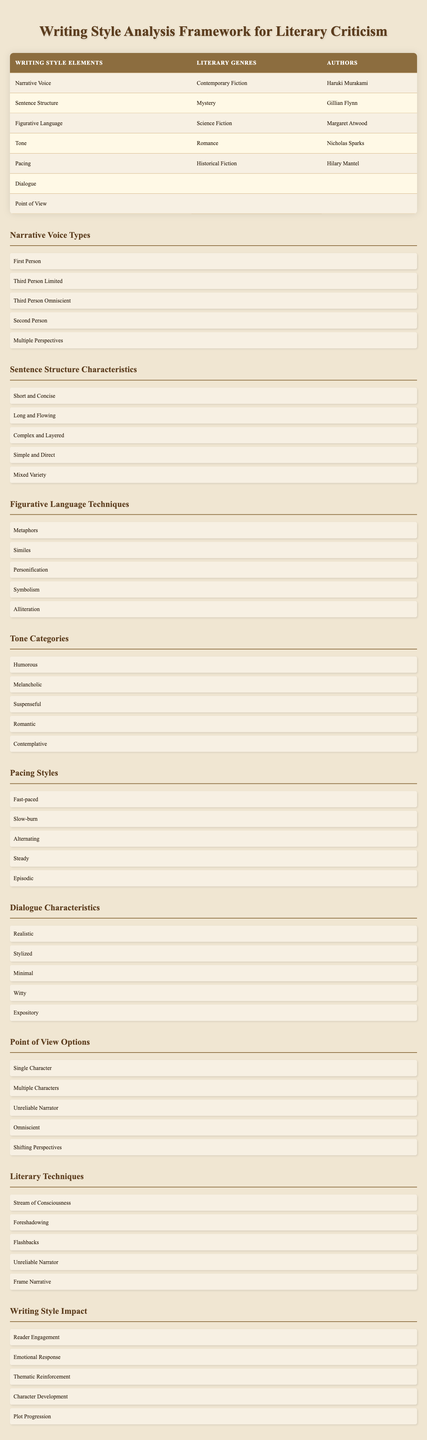What type of Narrative Voice is associated with Haruki Murakami? The table indicates that Haruki Murakami's work features a Narrative Voice in Contemporary Fiction. Although specific voice type isn't listed for him here, he often employs First Person in his narratives.
Answer: First Person Which author is linked to the Sentence Structure element in Mystery genre? According to the table, Gillian Flynn’s work relates to the Sentence Structure characteristic in the Mystery genre as shown in the corresponding row.
Answer: Gillian Flynn Is there a Dialogue characteristic directly provided in the table? The table lists a row for Dialogue but does not specify any authors or genres associated with it, indicating that no specific information is provided for this element.
Answer: No Which author is linked to Tone in the Romance genre? The table directly connects Nicholas Sparks to the Tone characteristic in the Romance genre, as shown in the respective row.
Answer: Nicholas Sparks Can you identify two Literary Genres represented in the table? The table lists Contemporary Fiction, Mystery, Science Fiction, Romance, and Historical Fiction as Literary Genres. Choosing any two of these would be acceptable, e.g., Contemporary Fiction and Mystery.
Answer: Contemporary Fiction and Mystery Which author writes in the Science Fiction genre and is associated with Figurative Language? The table shows that Margaret Atwood's work is associated with the Figurative Language element in the Science Fiction genre.
Answer: Margaret Atwood How many unique Narrative Voice Types are mentioned in the framework? The framework lists a total of five unique Narrative Voice Types: First Person, Third Person Limited, Third Person Omniscient, Second Person, and Multiple Perspectives. Therefore, the total is five.
Answer: Five What is the relationship between Pacing and Hilary Mantel's writing style? The table indicates that Hilary Mantel is associated with the Pacing element in the Historical Fiction genre. This implies her works incorporate a specific pacing technique relevant to this genre.
Answer: Pacing element in Historical Fiction Does the table suggest that all authors are assigned a writing style element? The table shows that some writing style elements like Dialogue and Point of View do not have any authors assigned to them, indicating not all authors are linked to a writing style element in the table.
Answer: No 